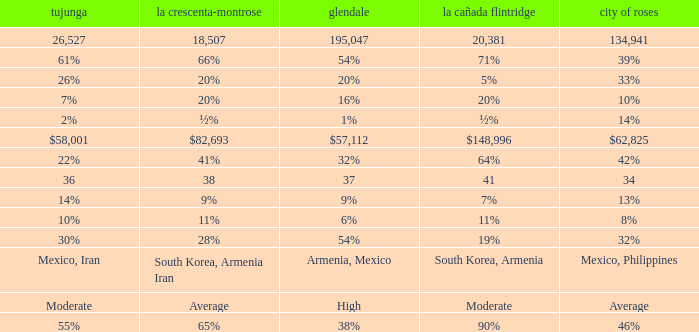What is the percentage of Glendale when La Canada Flintridge is 5%? 20%. 